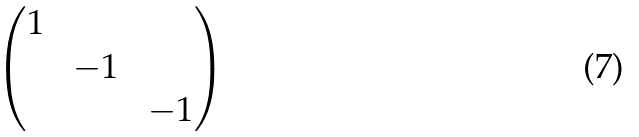<formula> <loc_0><loc_0><loc_500><loc_500>\begin{pmatrix} 1 \, & & \\ & \, - 1 \, & \\ & & \, - 1 \end{pmatrix}</formula> 